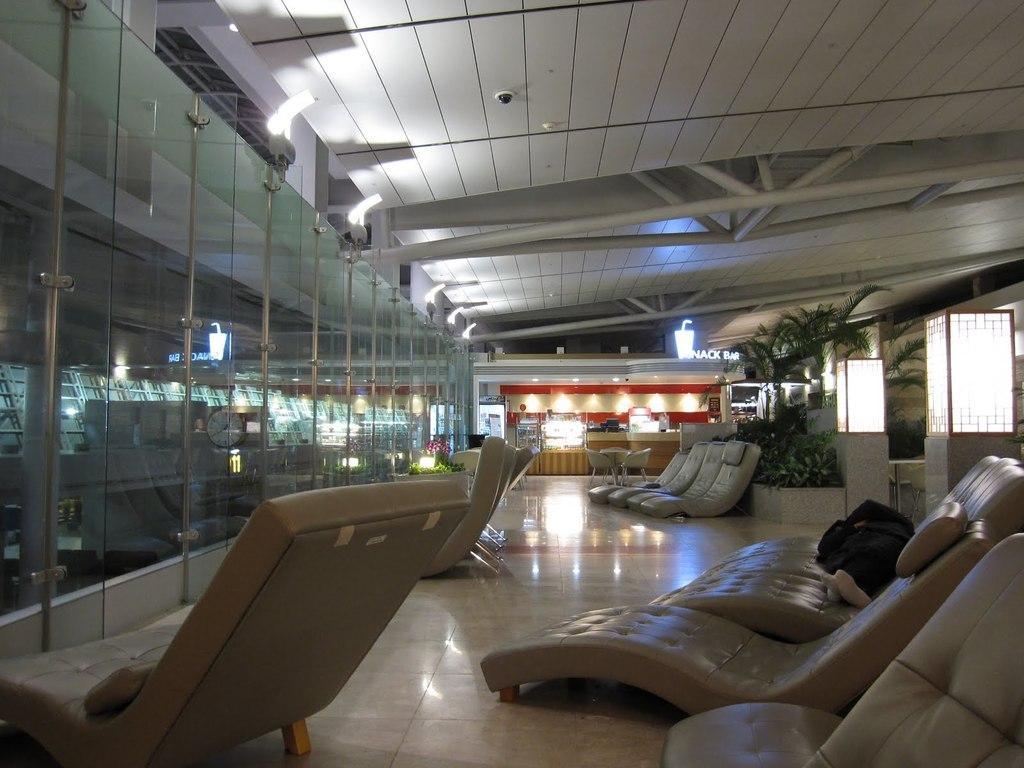Could you give a brief overview of what you see in this image? This picture shows a number of chairs in a place. In the background there are some plants, trees and light where there is a reception. We can observe some glasses in the left side. 